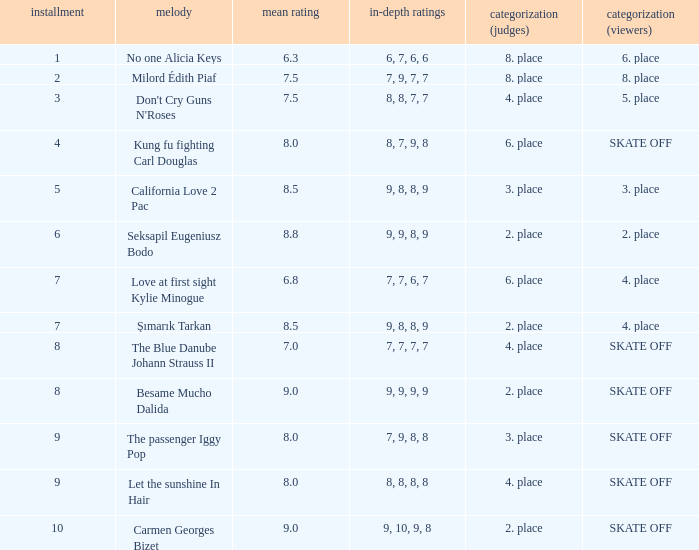Name the classification for 9, 9, 8, 9 2. place. 